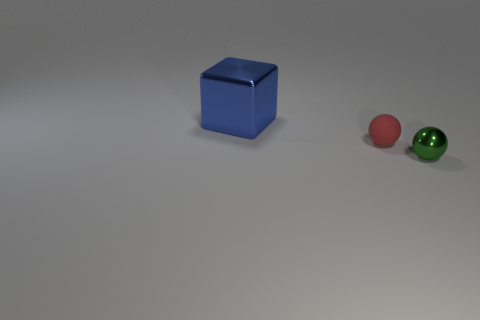What number of objects are either things right of the blue metallic cube or big yellow cylinders?
Provide a short and direct response. 2. There is a metal thing that is in front of the large metallic thing; what number of green metallic balls are to the left of it?
Provide a short and direct response. 0. Are there more green spheres that are on the left side of the blue thing than big blue things?
Your answer should be compact. No. There is a thing that is right of the big blue cube and behind the small green metal object; what size is it?
Give a very brief answer. Small. What is the shape of the thing that is to the right of the large metal object and to the left of the green sphere?
Your answer should be compact. Sphere. Is there a metal ball behind the thing behind the tiny thing that is behind the green thing?
Provide a succinct answer. No. What number of objects are tiny things that are left of the small green sphere or tiny spheres that are in front of the small red rubber sphere?
Your answer should be compact. 2. Does the small object in front of the small red thing have the same material as the small red thing?
Your response must be concise. No. There is a thing that is both left of the green ball and on the right side of the big blue thing; what material is it made of?
Give a very brief answer. Rubber. There is a metal thing that is in front of the small sphere that is to the left of the green object; what is its color?
Provide a short and direct response. Green. 